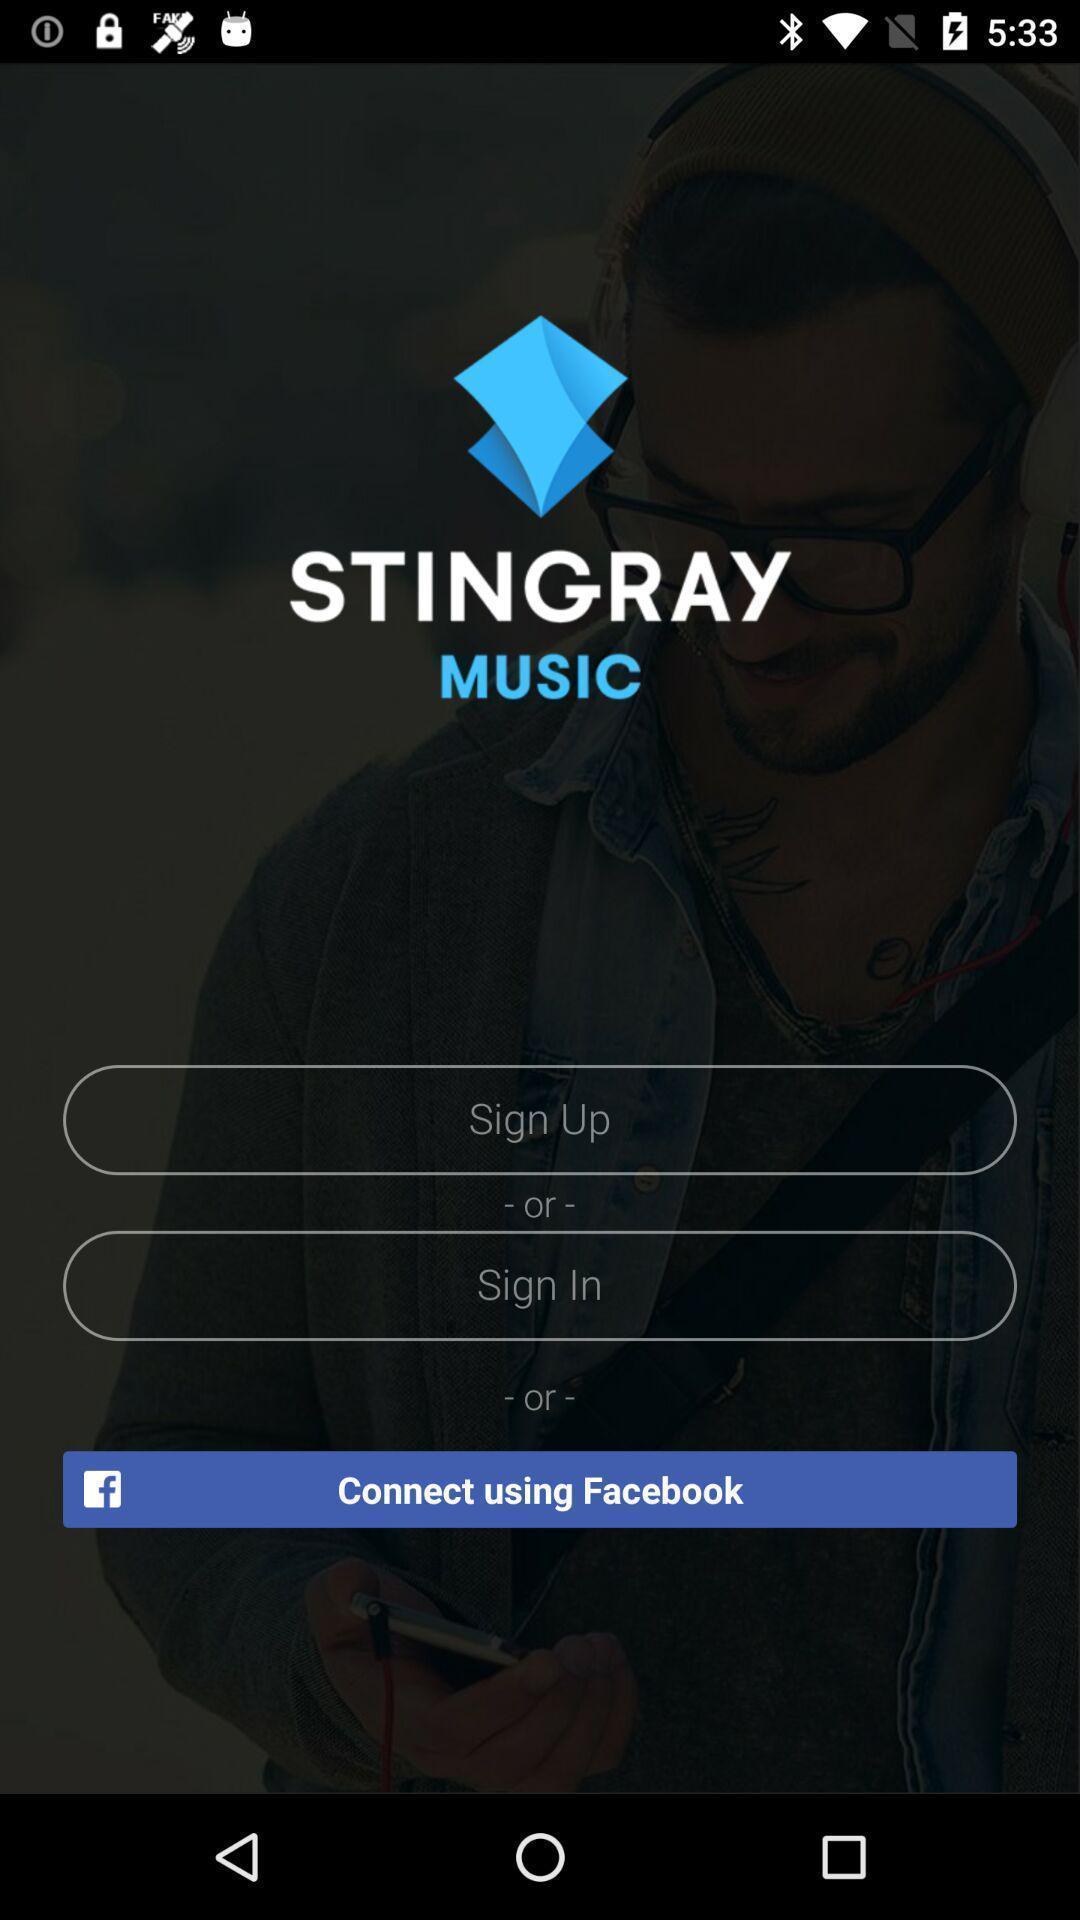What is the overall content of this screenshot? Sign up/ sign in page. 